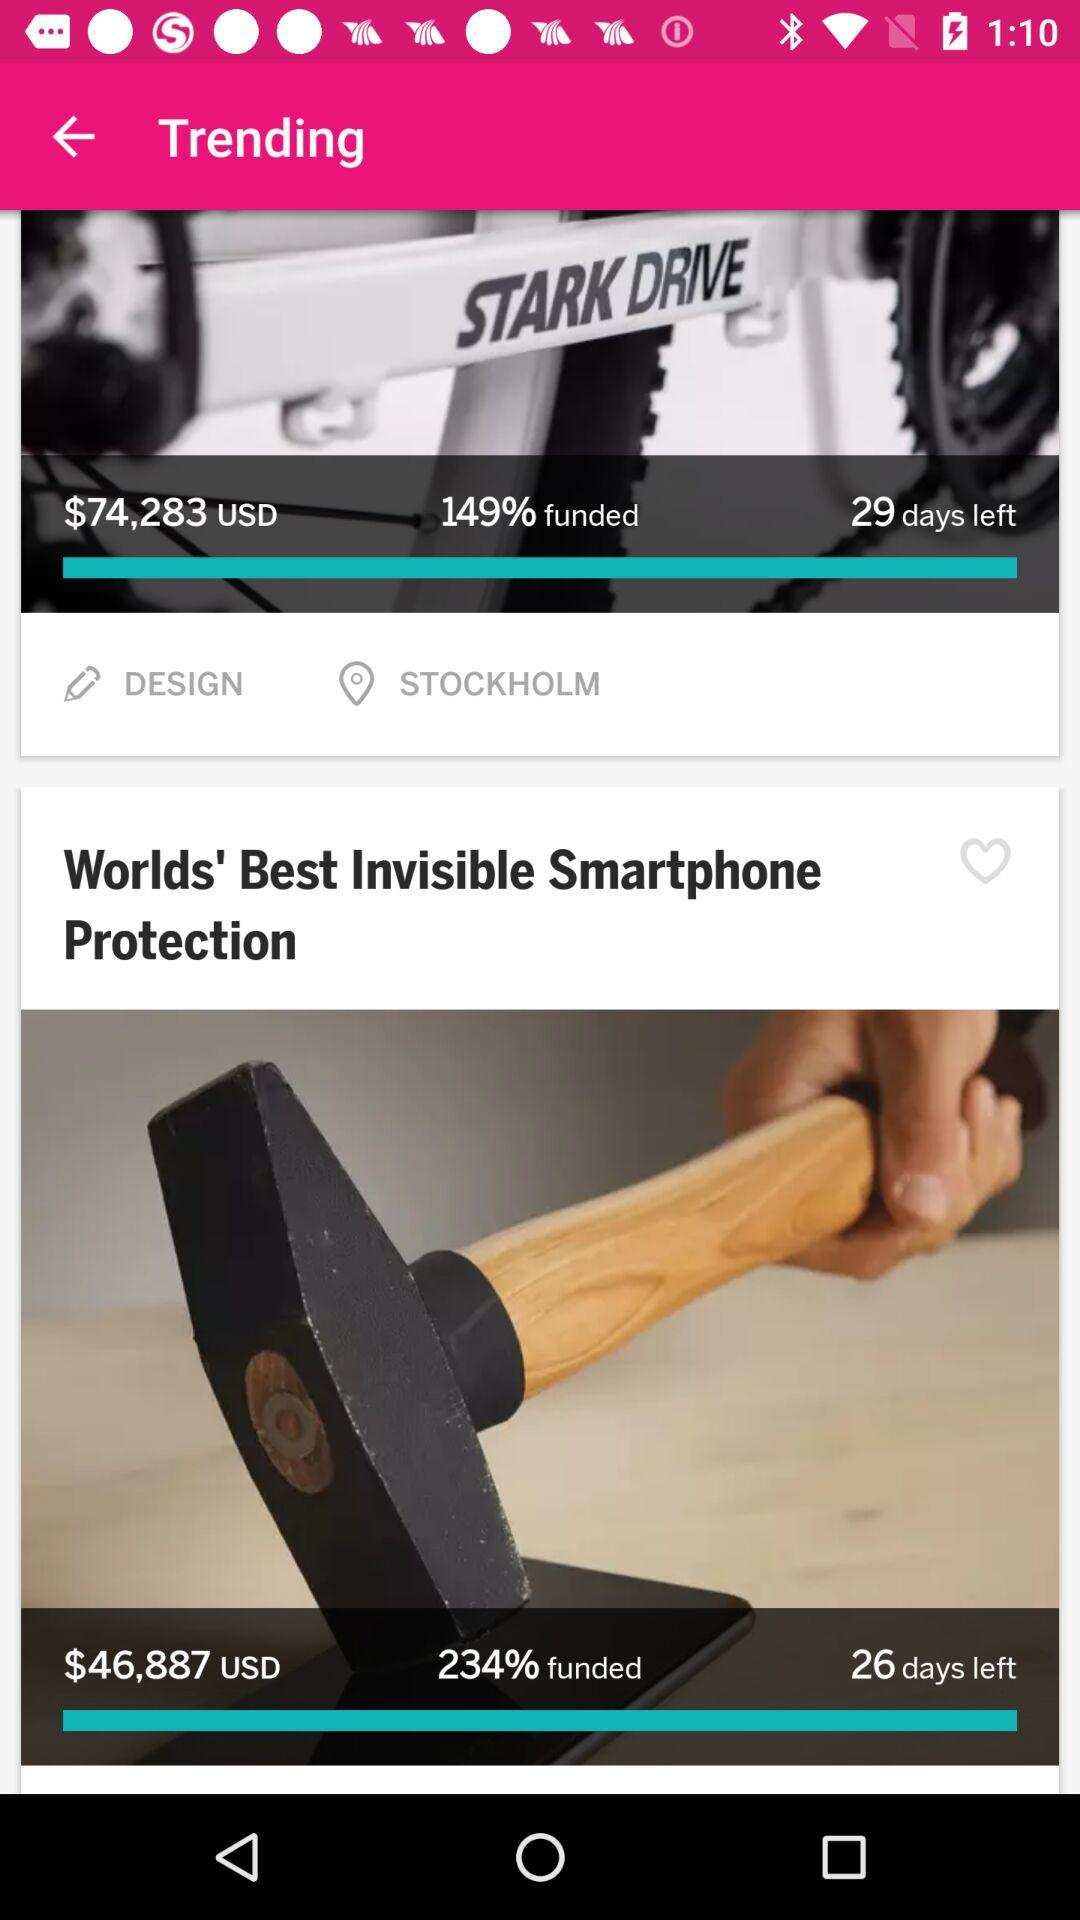What is the price of a smartphone? The price of a smartphone is $46,887 USD. 